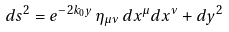Convert formula to latex. <formula><loc_0><loc_0><loc_500><loc_500>d s ^ { 2 } = e ^ { - 2 k _ { 0 } y } \, \eta _ { \mu \nu } \, d x ^ { \mu } d x ^ { \nu } + d y ^ { 2 }</formula> 